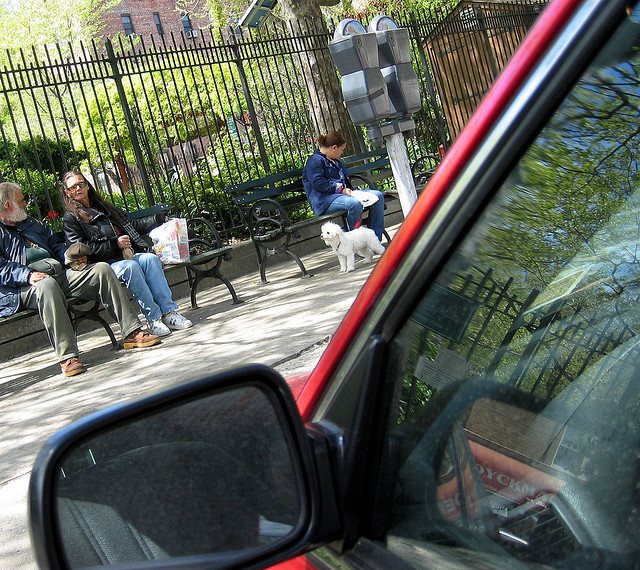Identify and read out the text in this image. YCKM 